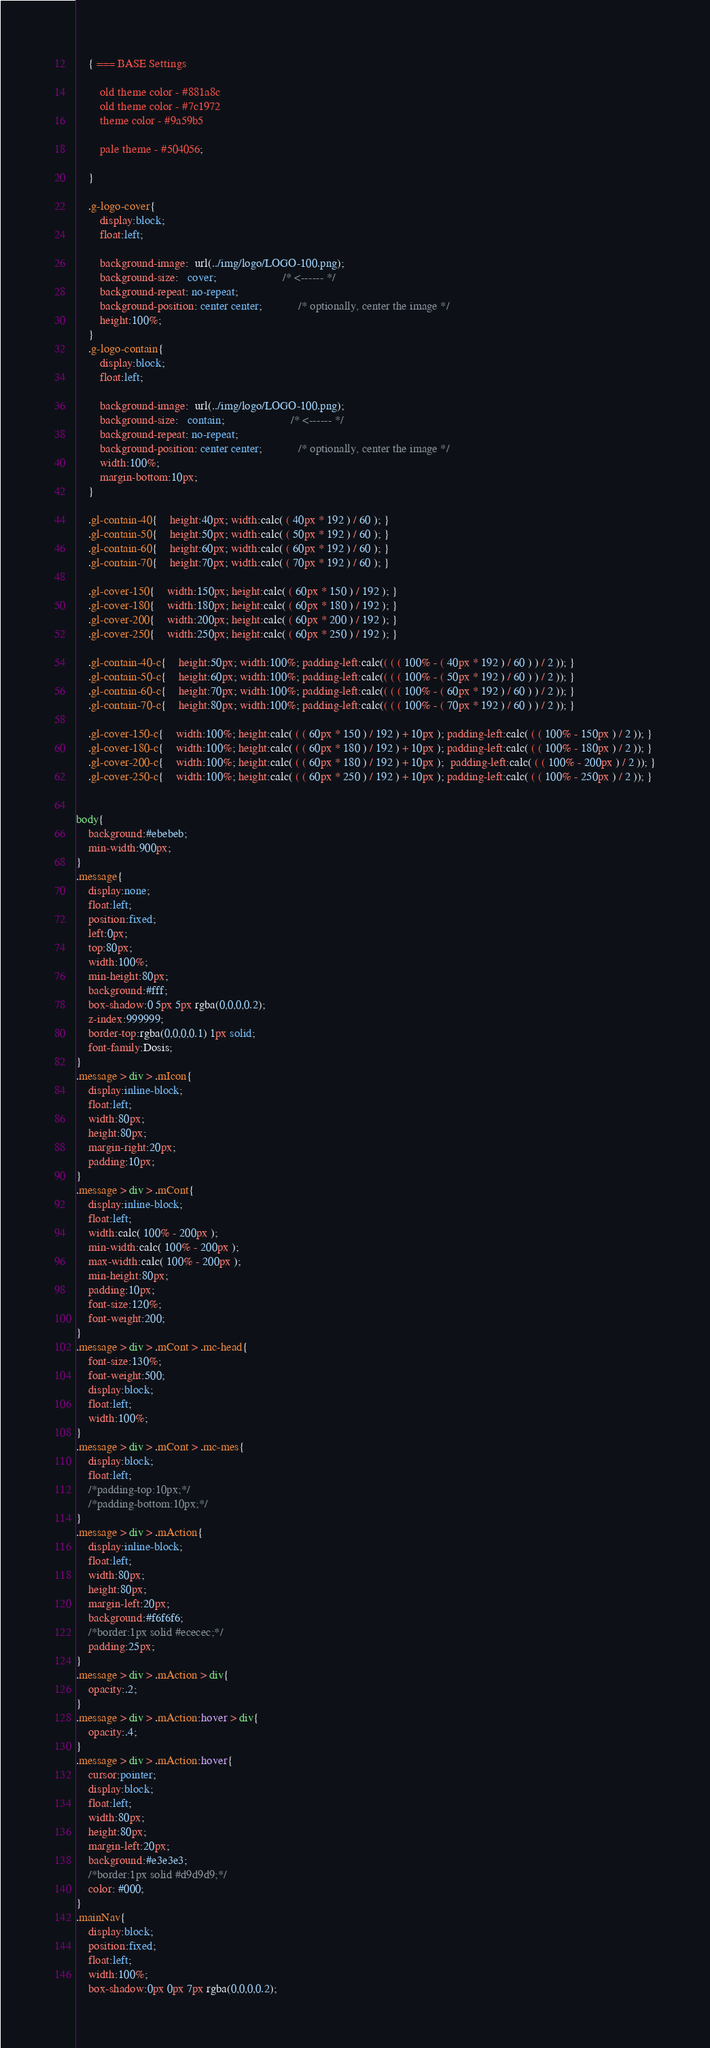<code> <loc_0><loc_0><loc_500><loc_500><_CSS_>

	{ === BASE Settings

		old theme color - #881a8c
		old theme color - #7c1972
		theme color - #9a59b5

		pale theme - #504056;

	}

	.g-logo-cover{
		display:block;
		float:left;

		background-image:  url(../img/logo/LOGO-100.png);
		background-size:   cover;                      /* <------ */
		background-repeat: no-repeat;
		background-position: center center;            /* optionally, center the image */
		height:100%;
	}
	.g-logo-contain{
		display:block;
		float:left;

		background-image:  url(../img/logo/LOGO-100.png);
		background-size:   contain;                      /* <------ */
		background-repeat: no-repeat;
		background-position: center center;            /* optionally, center the image */
		width:100%;
		margin-bottom:10px;
	}

	.gl-contain-40{	height:40px; width:calc( ( 40px * 192 ) / 60 ); }
	.gl-contain-50{	height:50px; width:calc( ( 50px * 192 ) / 60 ); }
	.gl-contain-60{	height:60px; width:calc( ( 60px * 192 ) / 60 ); }
	.gl-contain-70{	height:70px; width:calc( ( 70px * 192 ) / 60 ); }

	.gl-cover-150{	width:150px; height:calc( ( 60px * 150 ) / 192 ); }
	.gl-cover-180{	width:180px; height:calc( ( 60px * 180 ) / 192 ); }
	.gl-cover-200{	width:200px; height:calc( ( 60px * 200 ) / 192 ); }
	.gl-cover-250{	width:250px; height:calc( ( 60px * 250 ) / 192 ); }

	.gl-contain-40-c{	height:50px; width:100%; padding-left:calc(( ( ( 100% - ( 40px * 192 ) / 60 ) ) / 2 )); }
	.gl-contain-50-c{	height:60px; width:100%; padding-left:calc(( ( ( 100% - ( 50px * 192 ) / 60 ) ) / 2 )); }
	.gl-contain-60-c{	height:70px; width:100%; padding-left:calc(( ( ( 100% - ( 60px * 192 ) / 60 ) ) / 2 )); }
	.gl-contain-70-c{	height:80px; width:100%; padding-left:calc(( ( ( 100% - ( 70px * 192 ) / 60 ) ) / 2 )); }

	.gl-cover-150-c{	width:100%; height:calc( ( ( 60px * 150 ) / 192 ) + 10px ); padding-left:calc( ( ( 100% - 150px ) / 2 )); }
	.gl-cover-180-c{	width:100%; height:calc( ( ( 60px * 180 ) / 192 ) + 10px ); padding-left:calc( ( ( 100% - 180px ) / 2 )); }
	.gl-cover-200-c{	width:100%; height:calc( ( ( 60px * 180 ) / 192 ) + 10px );  padding-left:calc( ( ( 100% - 200px ) / 2 )); }
	.gl-cover-250-c{	width:100%; height:calc( ( ( 60px * 250 ) / 192 ) + 10px ); padding-left:calc( ( ( 100% - 250px ) / 2 )); }


body{
	background:#ebebeb;
	min-width:900px;
}
.message{
	display:none;
	float:left;
	position:fixed;
	left:0px;
	top:80px;
	width:100%;
	min-height:80px;
	background:#fff;
	box-shadow:0 5px 5px rgba(0,0,0,0.2);
	z-index:999999;
	border-top:rgba(0,0,0,0.1) 1px solid;
	font-family:Dosis;
}
.message > div > .mIcon{
	display:inline-block;
	float:left;
	width:80px;
	height:80px;
	margin-right:20px;
	padding:10px;
}
.message > div > .mCont{
	display:inline-block;
	float:left;
	width:calc( 100% - 200px );
	min-width:calc( 100% - 200px );
	max-width:calc( 100% - 200px );
	min-height:80px;
	padding:10px;
	font-size:120%;
	font-weight:200;
}
.message > div > .mCont > .mc-head{
	font-size:130%;
	font-weight:500;
	display:block;
	float:left;
	width:100%;
}
.message > div > .mCont > .mc-mes{
	display:block;
	float:left;
	/*padding-top:10px;*/
	/*padding-bottom:10px;*/
}
.message > div > .mAction{
	display:inline-block;
	float:left;
	width:80px;
	height:80px;
	margin-left:20px;
	background:#f6f6f6;
	/*border:1px solid #ececec;*/
	padding:25px;
}
.message > div > .mAction > div{
	opacity:.2;
}
.message > div > .mAction:hover > div{
	opacity:.4;
}
.message > div > .mAction:hover{
	cursor:pointer;
	display:block;
	float:left;
	width:80px;
	height:80px;
	margin-left:20px;
	background:#e3e3e3;
	/*border:1px solid #d9d9d9;*/
	color: #000;
}
.mainNav{
	display:block;
	position:fixed;
	float:left;
	width:100%;
	box-shadow:0px 0px 7px rgba(0,0,0,0.2);</code> 